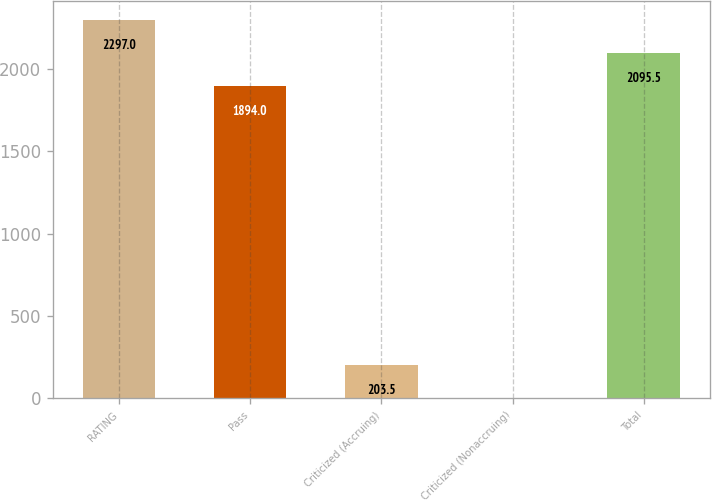Convert chart. <chart><loc_0><loc_0><loc_500><loc_500><bar_chart><fcel>RATING<fcel>Pass<fcel>Criticized (Accruing)<fcel>Criticized (Nonaccruing)<fcel>Total<nl><fcel>2297<fcel>1894<fcel>203.5<fcel>2<fcel>2095.5<nl></chart> 